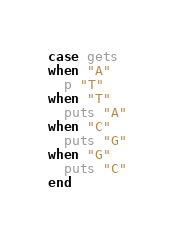<code> <loc_0><loc_0><loc_500><loc_500><_Ruby_>case gets
when "A"
  p "T"
when "T"
  puts "A"
when "C"
  puts "G"
when "G"
  puts "C"
end
</code> 